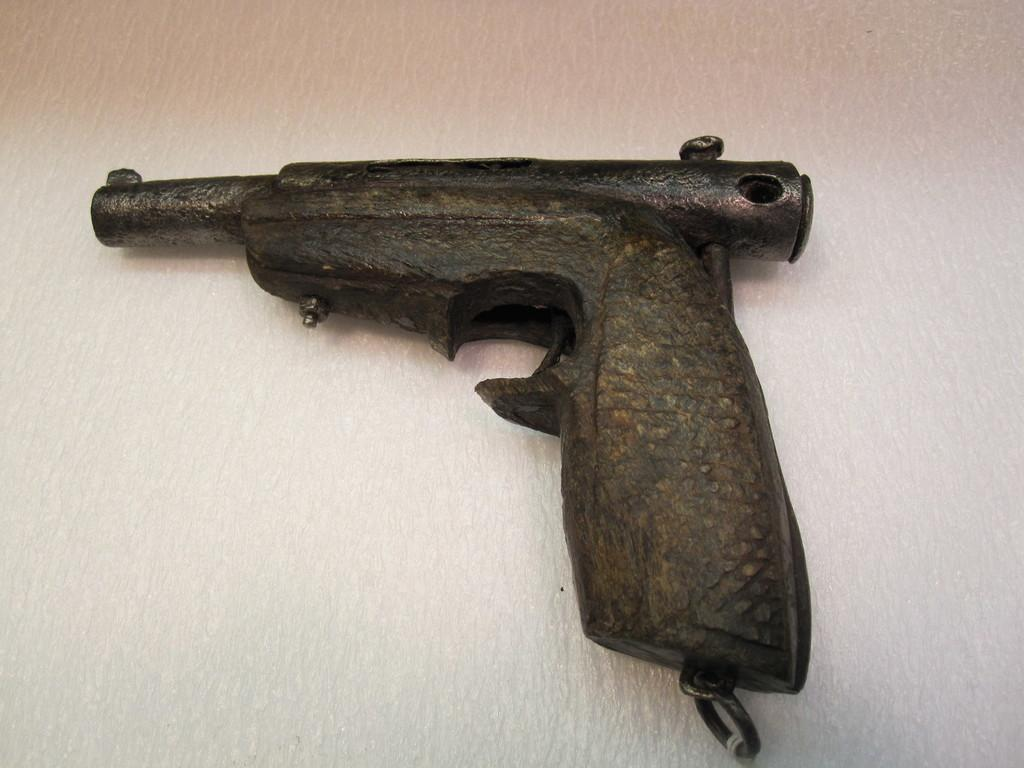What object is the main focus of the image? There is a gun in the image. What is the color of the surface on which the gun is placed? The gun is on a white surface. How many boys are playing the drums in the image? There are no boys or drums present in the image; it only features a gun on a white surface. 